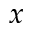Convert formula to latex. <formula><loc_0><loc_0><loc_500><loc_500>x</formula> 